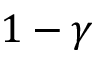Convert formula to latex. <formula><loc_0><loc_0><loc_500><loc_500>1 - \gamma</formula> 